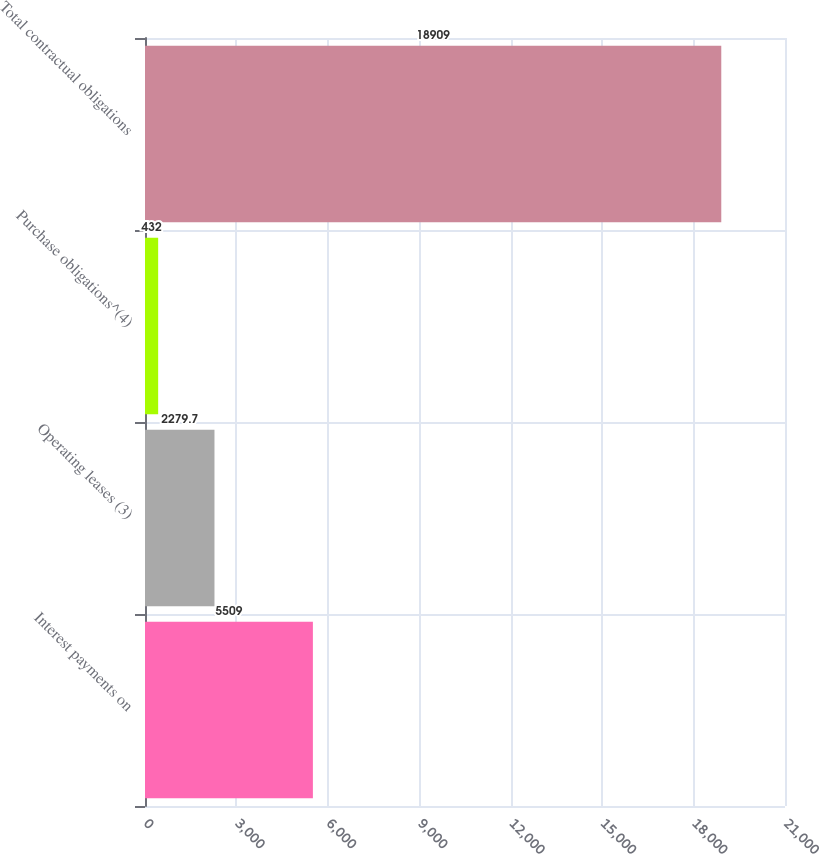Convert chart to OTSL. <chart><loc_0><loc_0><loc_500><loc_500><bar_chart><fcel>Interest payments on<fcel>Operating leases (3)<fcel>Purchase obligations^(4)<fcel>Total contractual obligations<nl><fcel>5509<fcel>2279.7<fcel>432<fcel>18909<nl></chart> 